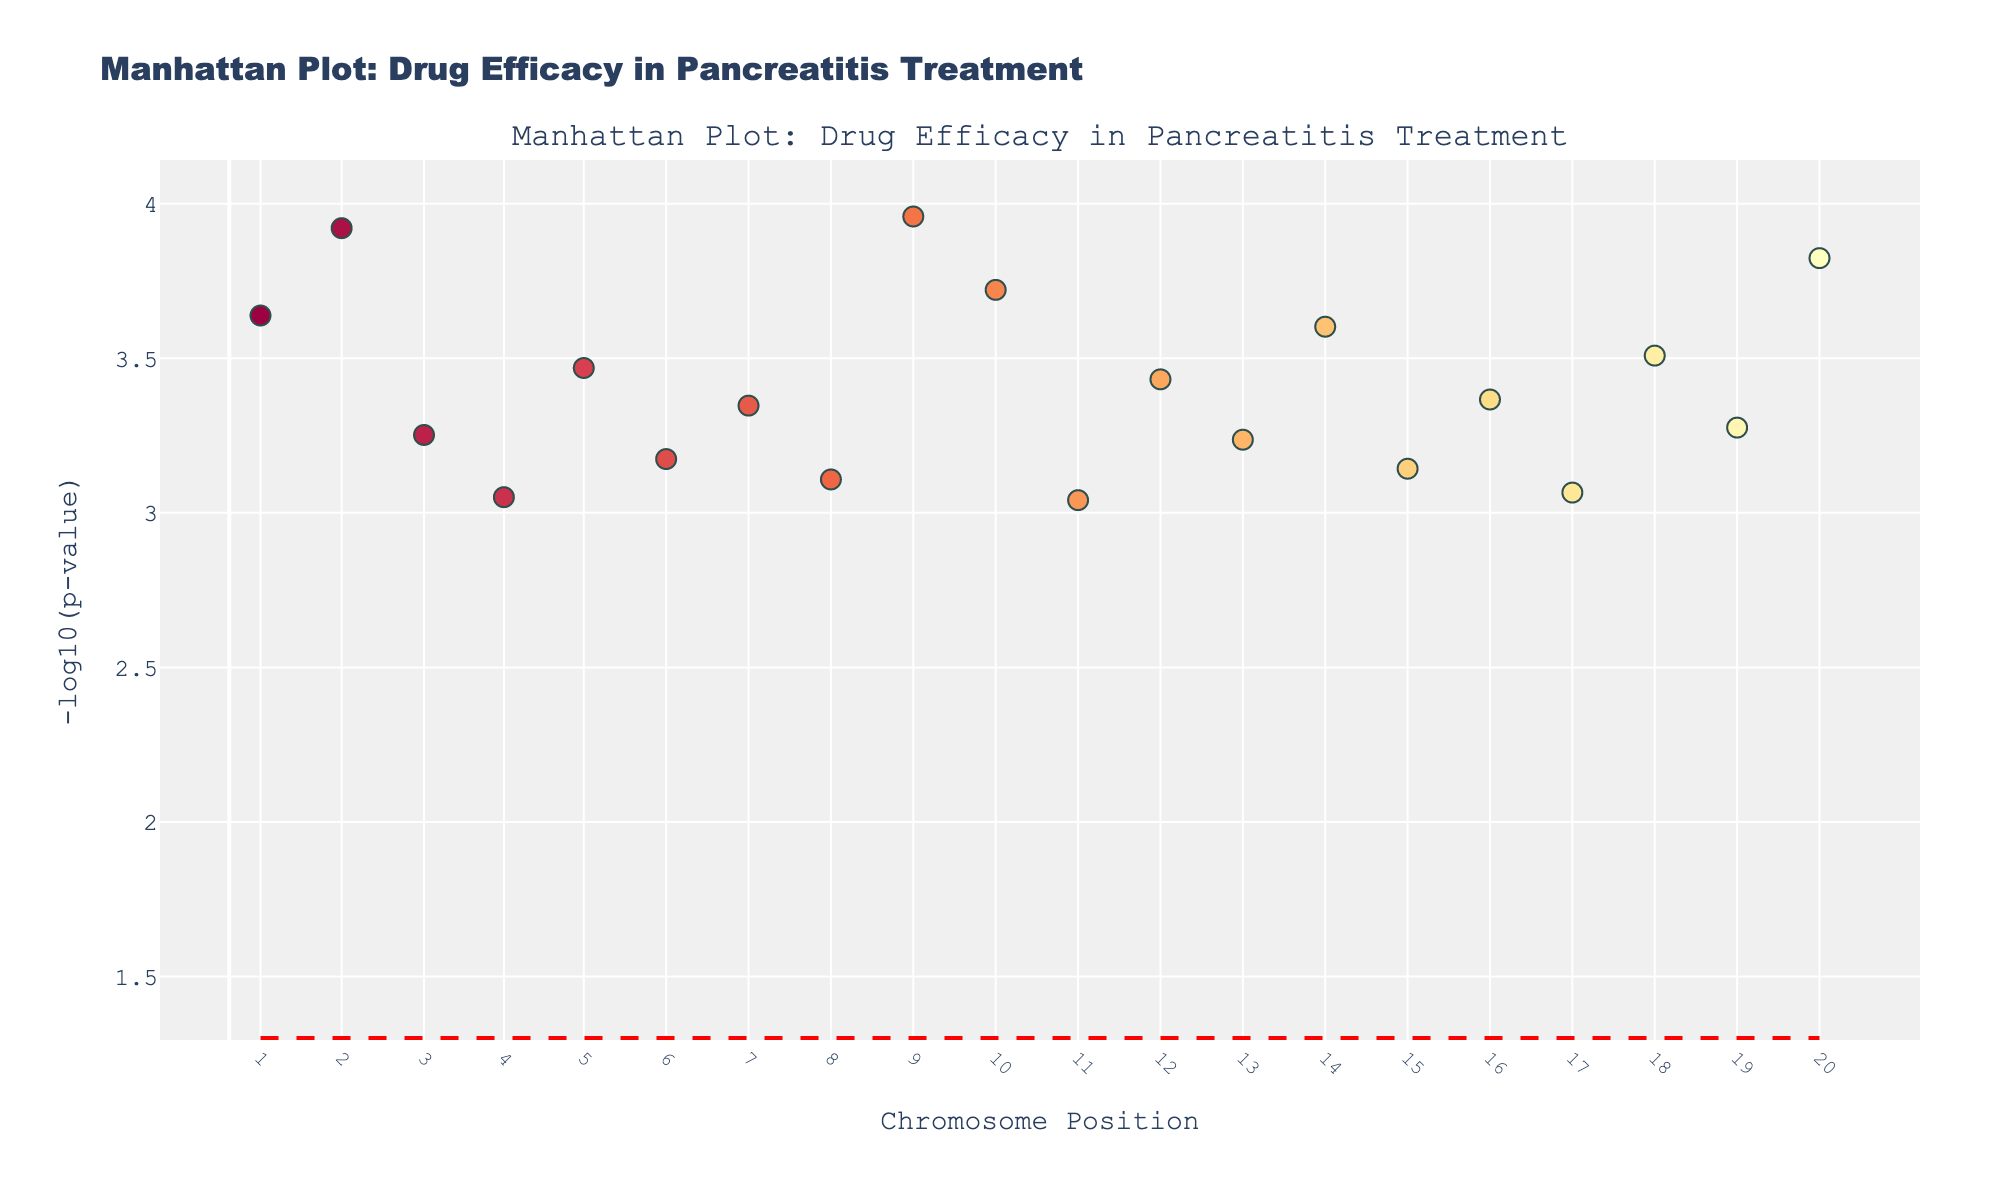What does the y-axis represent in the figure? The y-axis represents the -log10(p-value) for the side effects associated with each drug. This transformation is done to better visualize small p-values.
Answer: -log10(p-value) Which drug has the most significant p-value against side effects, and what is that side effect? The most significant p-value corresponds to the highest -log10(p-value) on the y-axis. The drug with the highest point is Octreotide, with the side effect "Diarrhea".
Answer: Octreotide, Diarrhea What is the significance line value, and what does it indicate? The significance line is at -log10(0.05). It indicates the threshold below which p-values are considered statistically significant. Any point above this line suggests a significant p-value.
Answer: -log10(0.05) How many drugs have significant p-values related to their side effects? Compare the number of points above the significance line. There are multiple drugs with points above the line, including Octreotide, Omeprazole, Pancrelipase, and Pantoprazole.
Answer: Multiple drugs Which drug is associated with the side effect "Weight gain" and is it statistically significant? The drug associated with "Weight gain" is Pancrelipase. Since its point is above the significance line, it is considered statistically significant.
Answer: Pancrelipase, Yes Compare the significance of Pancrelipase and Prochlorperazine with respect to their side effects. Look at the position of points associated with Pancrelipase and Prochlorperazine. Pancrelipase (-log10(p-value) higher) is more significant than Prochlorperazine.
Answer: Pancrelipase more significant Are there more drugs with p-values above or below the significance threshold? Count the number of points above and below the significance line. There are fewer points above, hence more drugs have p-values below the significance threshold.
Answer: More below What side effect is Ranitidine associated with, and how significant is its p-value? Ranitidine is associated with "Skin rash". It has a point above the significance line, indicating it has a significant p-value.
Answer: Skin rash, significant Between Gabexate and Metoclopramide, which drug has a more significant p-value and what are their side effects? Compare the -log10(p-values) for both. Gabexate (Abdominal pain) has a higher -log10(p-value) hence more significant than Metoclopramide (Extrapyramidal symptoms).
Answer: Gabexate, Abdominal pain 